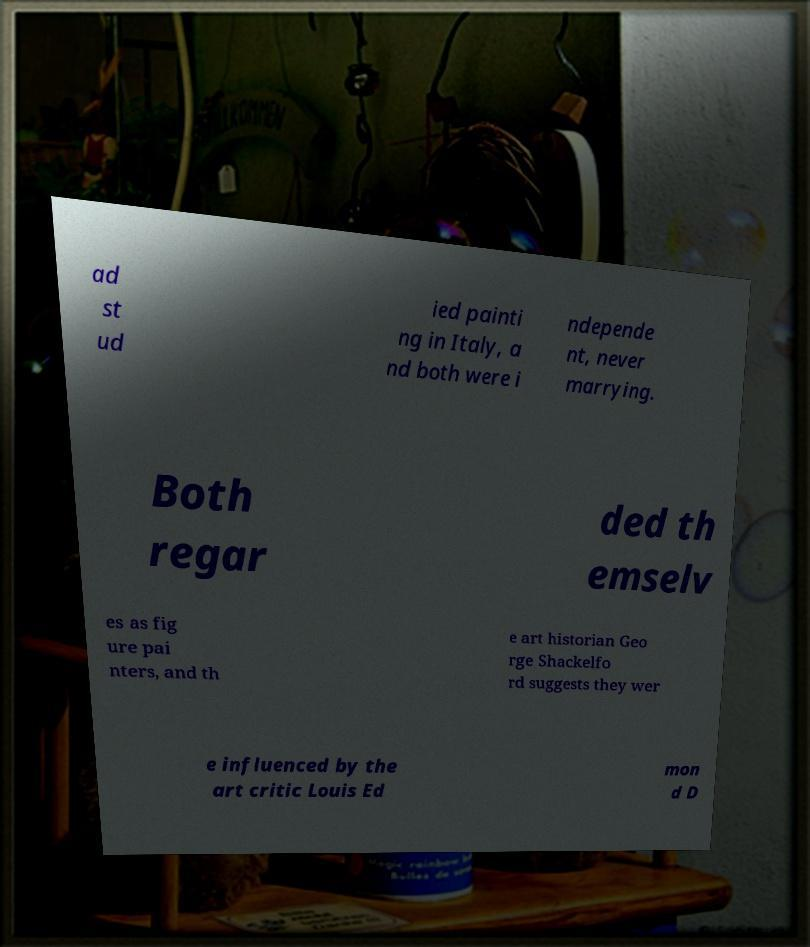Could you assist in decoding the text presented in this image and type it out clearly? ad st ud ied painti ng in Italy, a nd both were i ndepende nt, never marrying. Both regar ded th emselv es as fig ure pai nters, and th e art historian Geo rge Shackelfo rd suggests they wer e influenced by the art critic Louis Ed mon d D 